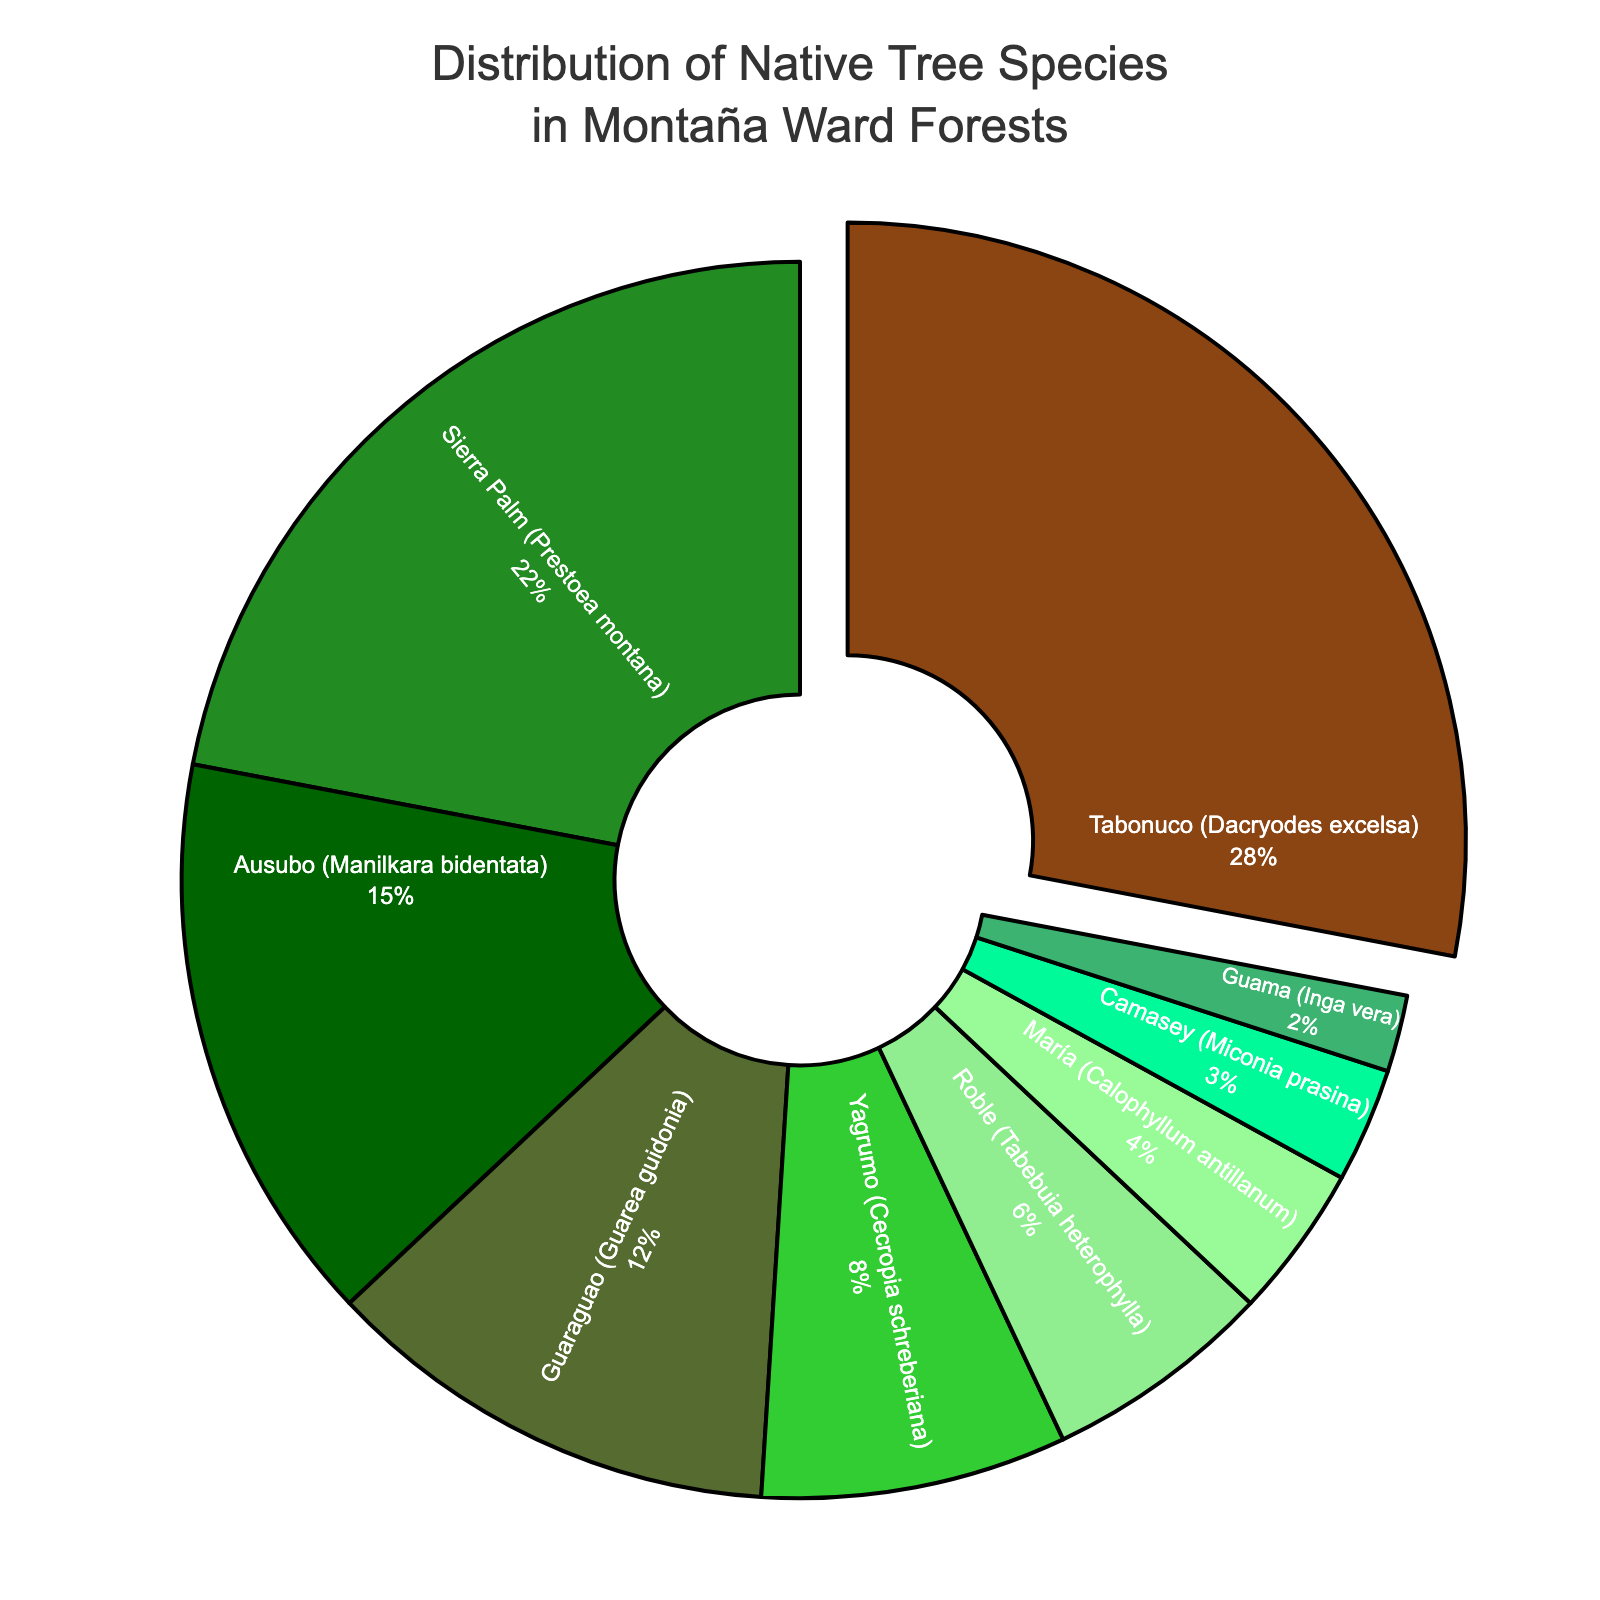Which species makes up the largest percentage of native trees in the forests surrounding Montaña ward? The figure shows "Tabonuco (Dacryodes excelsa)" being separated from the rest and it has the largest segment marked as 28%.
Answer: Tabonuco (Dacryodes excelsa) What is the combined percentage of Sierra Palm and Ausubo? Sierra Palm accounts for 22% and Ausubo makes up 15%. Adding these two, 22% + 15% equals 37%.
Answer: 37% Which species covers the least percentage of the forest? The figure shows that "Guama (Inga vera)" has the smallest segment with 2%.
Answer: Guama (Inga vera) How does the percentage of Tabonuco compare to the percentage of Guaraguao? Tabonuco has 28% while Guaraguao is at 12%. Tabonuco's percentage is more than double of Guaraguao's percentage.
Answer: Tabonuco is more than double Guaraguao What is the visual color representation of Sierra Palm on the chart? Sierra Palm has a green segment in the pie chart as indicated by its location and color placement in the figure.
Answer: Green Combined, what percentage of the trees are made up by Roble and María species? Roble represents 6% and María makes up 4%. Adding these, 6% + 4% equals 10%.
Answer: 10% Which species makes up less than 5% of the forest? María (4%), Camasey (3%), and Guama (2%) each contribute less than 5% of the forest tree species.
Answer: María, Camasey, and Guama What is the difference in percentage between Yagrumo and Guama? Yagrumo accounts for 8% while Guama represents 2%. Subtracting them, 8% - 2% equals 6%.
Answer: 6% If you combine the percentage of Guaraguao and Yagrumo, do they exceed the percentage of Tabonuco? Guaraguao accounts for 12% and Yagrumo for 8%. Adding these, 12% + 8% = 20%, which is less than Tabonuco's 28%.
Answer: No What portion of the chart does Roble occupy compared to Camasey? Roble occupies 6% while Camasey occupies 3%. This means Roble's portion is twice that of Camasey's.
Answer: Roble is twice Camasey 